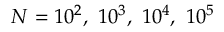<formula> <loc_0><loc_0><loc_500><loc_500>N = 1 0 ^ { 2 } , \ 1 0 ^ { 3 } , \ 1 0 ^ { 4 } , \ 1 0 ^ { 5 }</formula> 